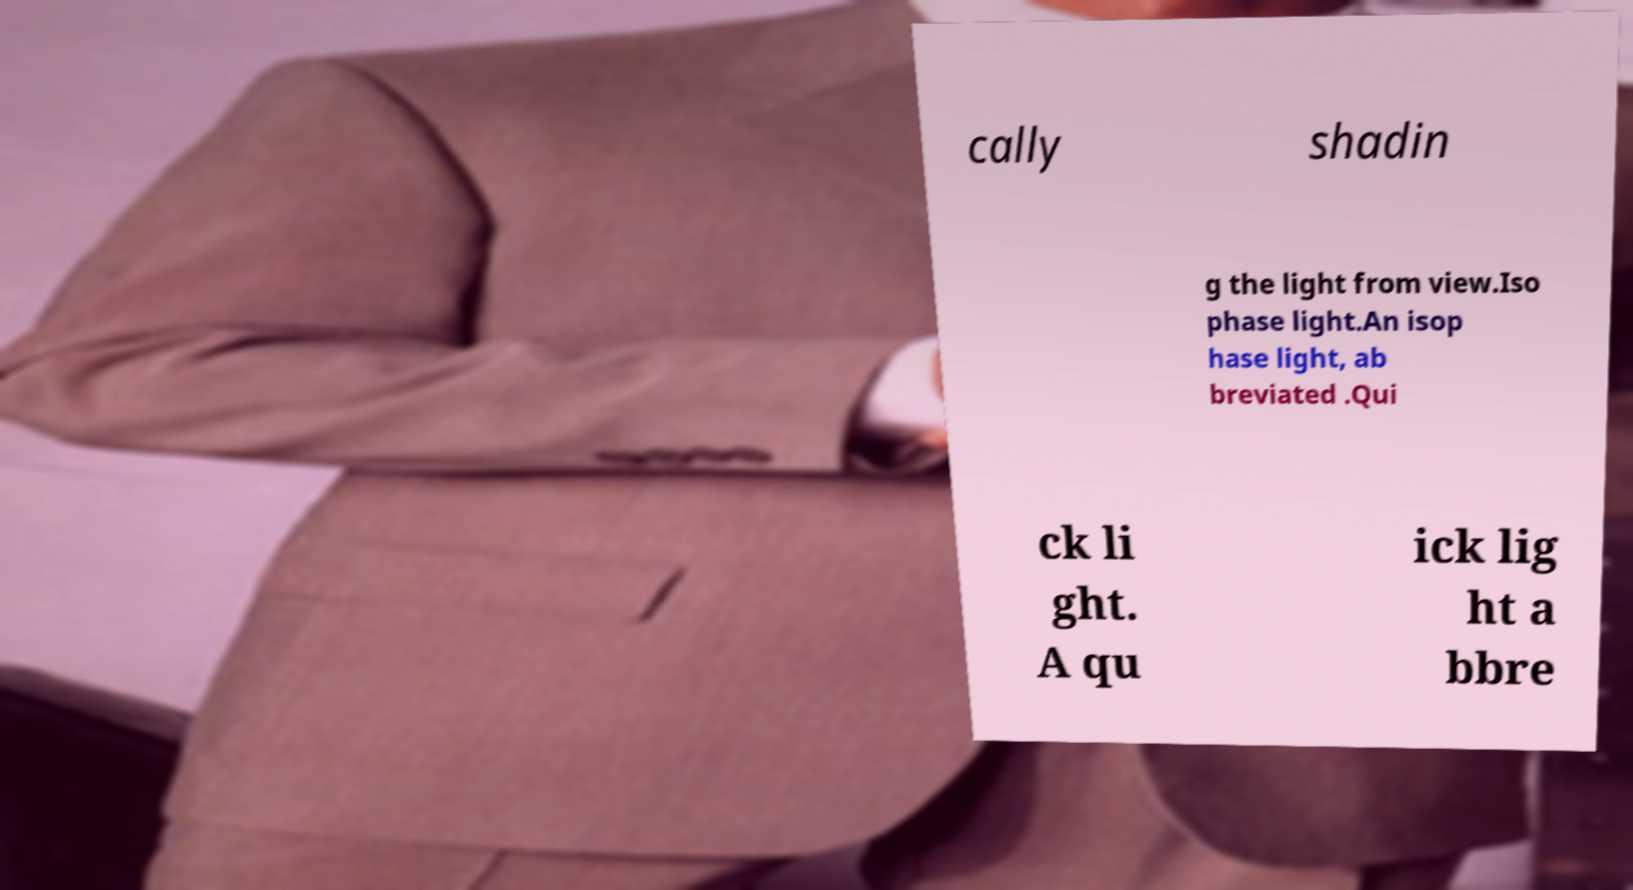Could you assist in decoding the text presented in this image and type it out clearly? cally shadin g the light from view.Iso phase light.An isop hase light, ab breviated .Qui ck li ght. A qu ick lig ht a bbre 